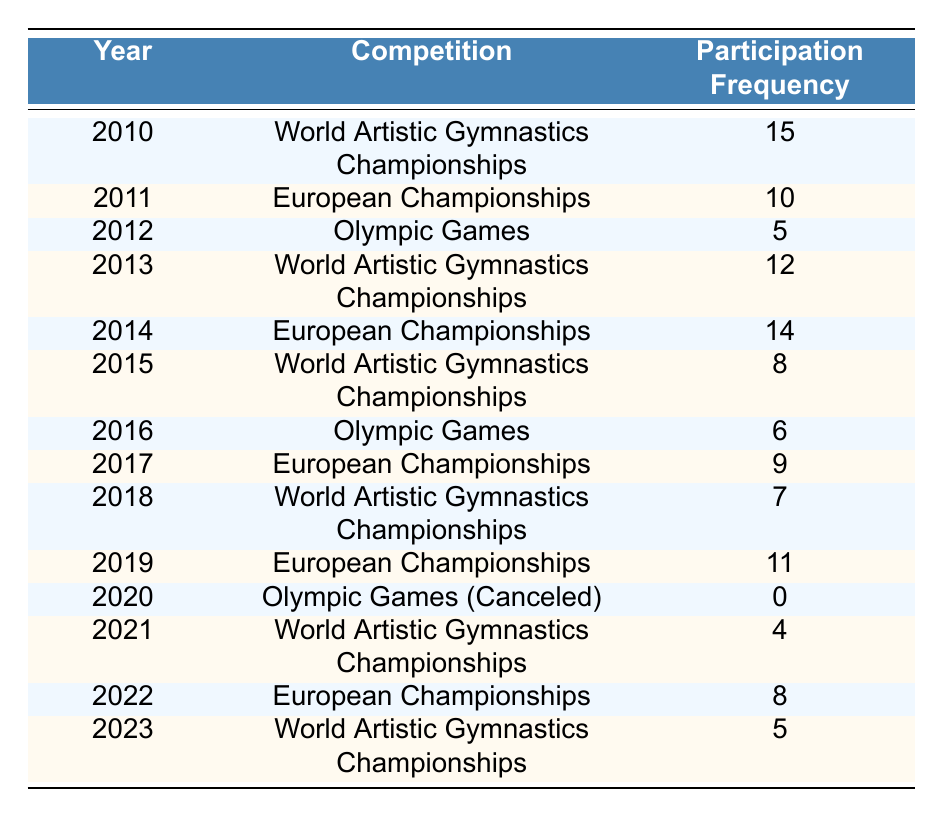What was the highest participation frequency in gymnastics competitions? By examining the participation frequency values in the table, the highest value is 15, which occurred in the year 2010 during the World Artistic Gymnastics Championships.
Answer: 15 Which year had the lowest participation frequency? Looking at the participation frequency values, the lowest is 0, which occurred in 2020 when the Olympic Games were canceled.
Answer: 0 How many times did the World Artistic Gymnastics Championships occur between 2010 and 2023? The World Artistic Gymnastics Championships occurred in 2010, 2013, 2015, 2021, and 2023. Counting these years gives a total of 5 occurrences.
Answer: 5 What is the average participation frequency for the European Championships? The European Championships took place in 2011, 2014, 2017, 2019, and 2022 with participation frequencies of 10, 14, 9, 11, and 8, respectively. The sum is 10 + 14 + 9 + 11 + 8 = 52, and there are 5 data points, so the average is 52 / 5 = 10.4.
Answer: 10.4 Did participation in the Olympic Games increase from 2012 to 2016? In 2012, the participation frequency was 5, and in 2016, it was 6. Since 6 is greater than 5, we can confirm that there was an increase in participation frequency from 2012 to 2016.
Answer: Yes Which competition had a participation frequency of 0 and in what year? The only event with a participation frequency of 0 is the Olympic Games in 2020.
Answer: Olympic Games (2020) What was the total participation frequency recorded for the World Artistic Gymnastics Championships from 2010 to 2023? Reviewing the data for the World Artistic Gymnastics Championships, the frequencies are 15 (2010), 12 (2013), 8 (2015), 4 (2021), and 5 (2023). Adding these together gives: 15 + 12 + 8 + 4 + 5 = 44.
Answer: 44 Was there any year between 2010 and 2023 with a participation frequency above 10 in the World Artistic Gymnastics Championships? Yes, the years 2010 (15) and 2013 (12) both have participation frequencies above 10.
Answer: Yes In 2019, how does the participation frequency in the European Championships compare to that of the World Artistic Gymnastics Championships in the same year? In 2019, the participation frequency for the European Championships was 11, while there was no World Artistic Gymnastics Championships that year, so it was 0. Thus, the European Championships had a higher frequency.
Answer: European Championships had a higher frequency 